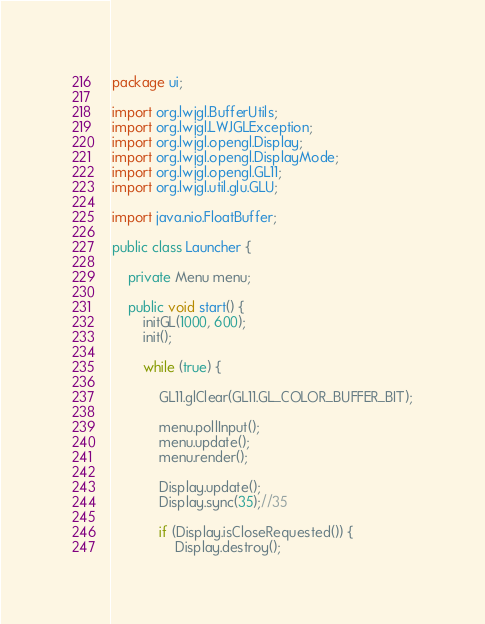<code> <loc_0><loc_0><loc_500><loc_500><_Java_>package ui;

import org.lwjgl.BufferUtils;
import org.lwjgl.LWJGLException;
import org.lwjgl.opengl.Display;
import org.lwjgl.opengl.DisplayMode;
import org.lwjgl.opengl.GL11;
import org.lwjgl.util.glu.GLU;

import java.nio.FloatBuffer;

public class Launcher {

    private Menu menu;

    public void start() {
        initGL(1000, 600);
        init();

        while (true) {

            GL11.glClear(GL11.GL_COLOR_BUFFER_BIT);

            menu.pollInput();
            menu.update();
            menu.render();

            Display.update();
            Display.sync(35);//35

            if (Display.isCloseRequested()) {
                Display.destroy();</code> 